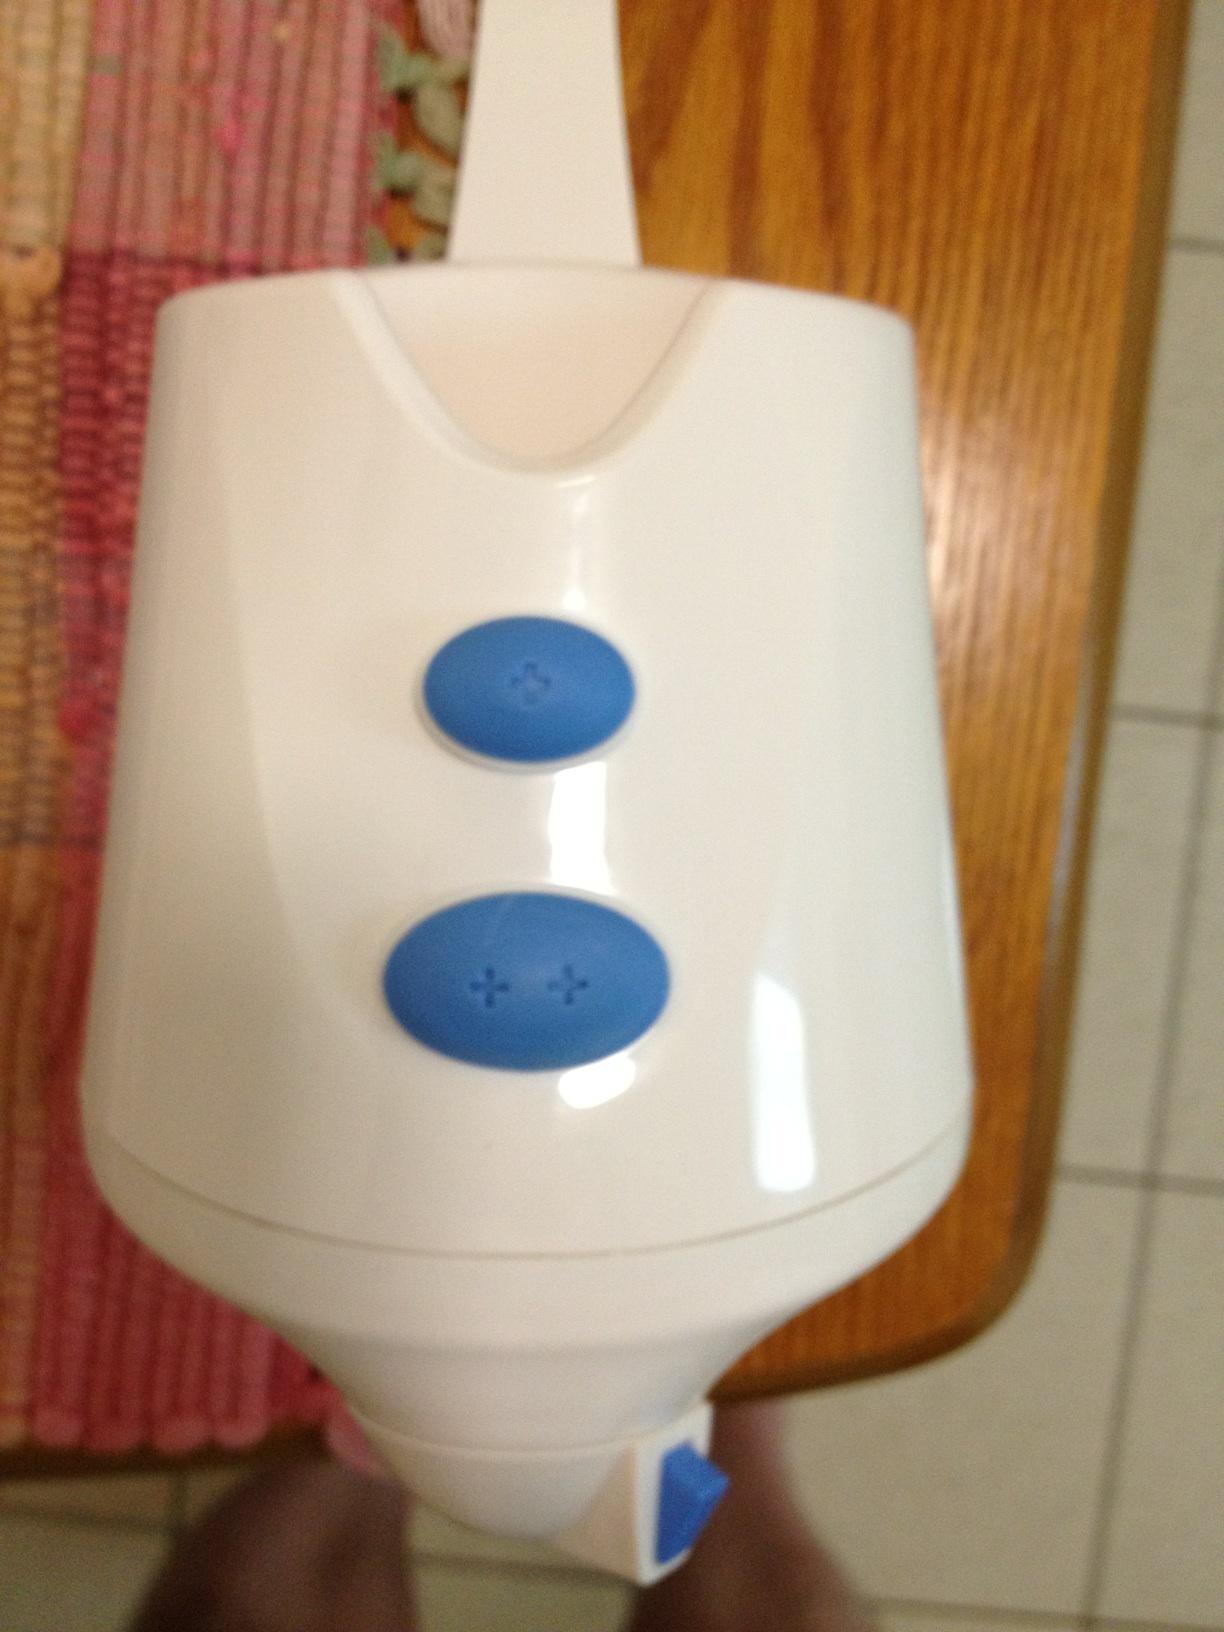What would be an ideal name for this device if it had the ability to clean the entire house on its own? A fitting name for such a futuristic and efficient device could be the 'HomeSanitizer 3000'. It would suggest a high-tech gadget designed to keep your home sparkling clean with minimal effort. 